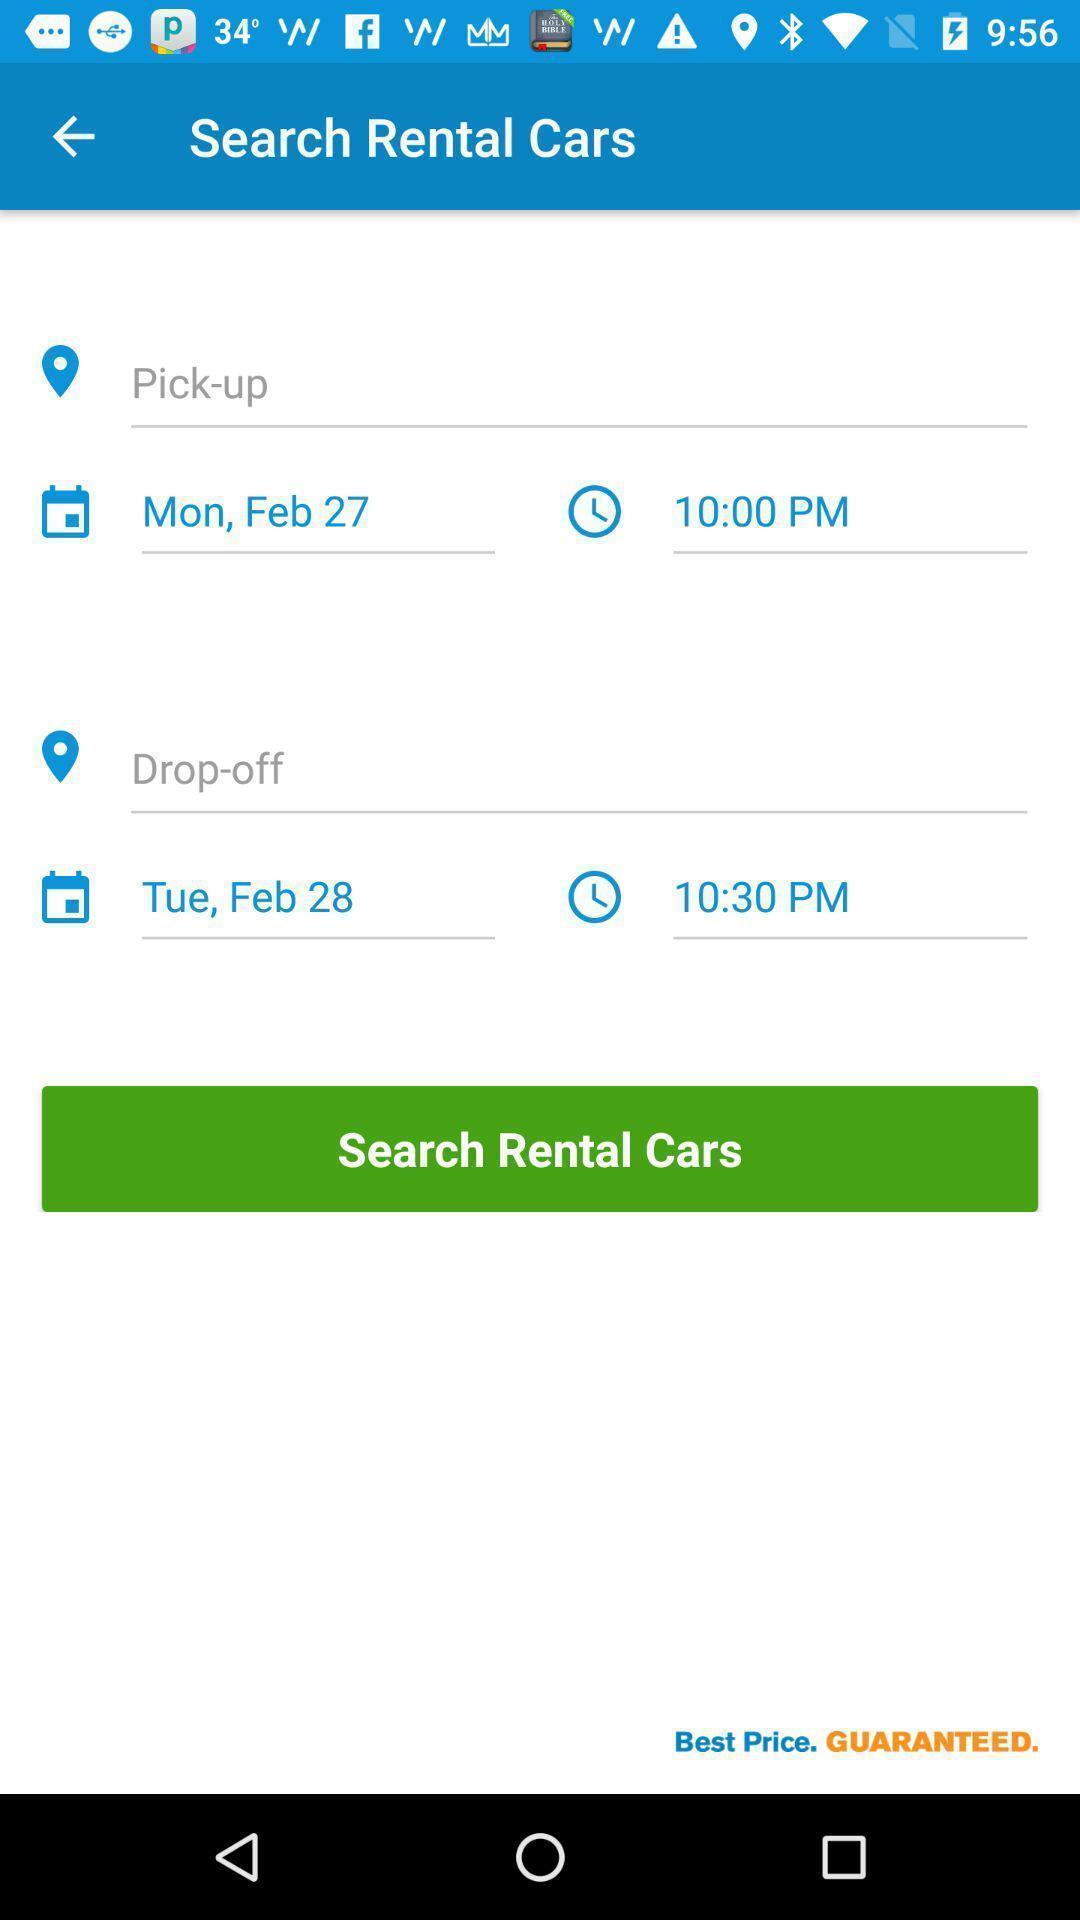Please provide a description for this image. Screen displaying the data of a car rental app. 